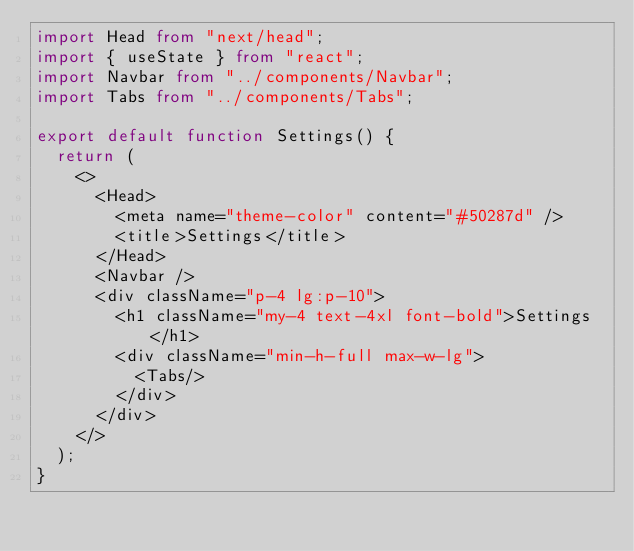Convert code to text. <code><loc_0><loc_0><loc_500><loc_500><_TypeScript_>import Head from "next/head";
import { useState } from "react";
import Navbar from "../components/Navbar";
import Tabs from "../components/Tabs";

export default function Settings() {
  return (
    <>
      <Head>
        <meta name="theme-color" content="#50287d" />
        <title>Settings</title>
      </Head>
      <Navbar />
      <div className="p-4 lg:p-10">
        <h1 className="my-4 text-4xl font-bold">Settings</h1>
        <div className="min-h-full max-w-lg">
          <Tabs/>
        </div>
      </div>
    </>
  );
}
</code> 